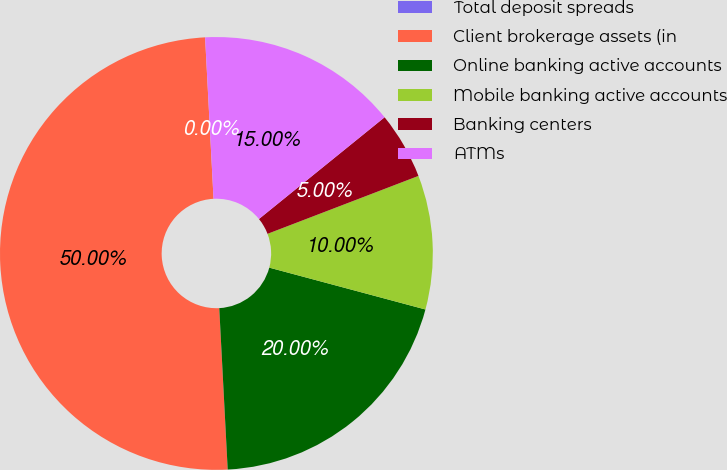<chart> <loc_0><loc_0><loc_500><loc_500><pie_chart><fcel>Total deposit spreads<fcel>Client brokerage assets (in<fcel>Online banking active accounts<fcel>Mobile banking active accounts<fcel>Banking centers<fcel>ATMs<nl><fcel>0.0%<fcel>50.0%<fcel>20.0%<fcel>10.0%<fcel>5.0%<fcel>15.0%<nl></chart> 